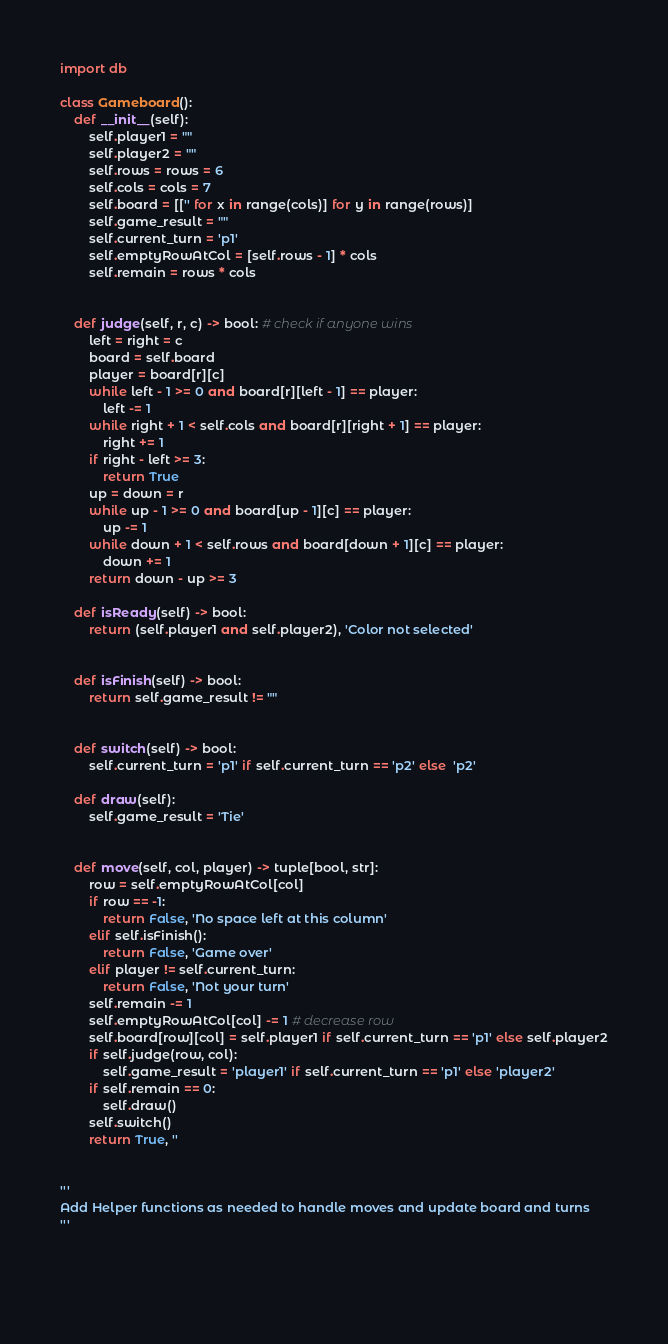Convert code to text. <code><loc_0><loc_0><loc_500><loc_500><_Python_>import db

class Gameboard():
    def __init__(self):
        self.player1 = ""
        self.player2 = ""
        self.rows = rows = 6
        self.cols = cols = 7
        self.board = [['' for x in range(cols)] for y in range(rows)]
        self.game_result = ""
        self.current_turn = 'p1'
        self.emptyRowAtCol = [self.rows - 1] * cols
        self.remain = rows * cols


    def judge(self, r, c) -> bool: # check if anyone wins
        left = right = c
        board = self.board
        player = board[r][c]
        while left - 1 >= 0 and board[r][left - 1] == player:
            left -= 1
        while right + 1 < self.cols and board[r][right + 1] == player:
            right += 1
        if right - left >= 3:
            return True
        up = down = r
        while up - 1 >= 0 and board[up - 1][c] == player:
            up -= 1
        while down + 1 < self.rows and board[down + 1][c] == player:
            down += 1
        return down - up >= 3

    def isReady(self) -> bool:
        return (self.player1 and self.player2), 'Color not selected'


    def isFinish(self) -> bool:
        return self.game_result != ""


    def switch(self) -> bool:
        self.current_turn = 'p1' if self.current_turn == 'p2' else  'p2'

    def draw(self):
        self.game_result = 'Tie'


    def move(self, col, player) -> tuple[bool, str]:
        row = self.emptyRowAtCol[col]
        if row == -1:
            return False, 'No space left at this column'
        elif self.isFinish():
            return False, 'Game over'
        elif player != self.current_turn:
            return False, 'Not your turn'
        self.remain -= 1
        self.emptyRowAtCol[col] -= 1 # decrease row
        self.board[row][col] = self.player1 if self.current_turn == 'p1' else self.player2
        if self.judge(row, col):
            self.game_result = 'player1' if self.current_turn == 'p1' else 'player2'
        if self.remain == 0:
            self.draw()
        self.switch()
        return True, ''


'''
Add Helper functions as needed to handle moves and update board and turns
'''


    
</code> 